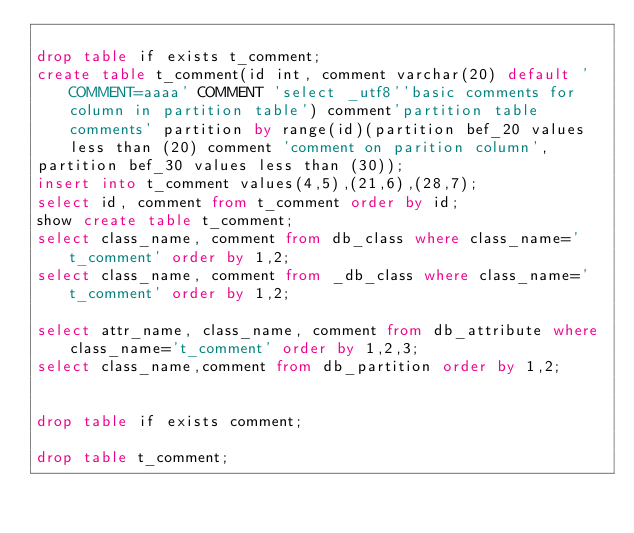<code> <loc_0><loc_0><loc_500><loc_500><_SQL_>
drop table if exists t_comment;
create table t_comment(id int, comment varchar(20) default 'COMMENT=aaaa' COMMENT 'select _utf8''basic comments for column in partition table') comment'partition table comments' partition by range(id)(partition bef_20 values less than (20) comment 'comment on parition column',
partition bef_30 values less than (30));
insert into t_comment values(4,5),(21,6),(28,7);
select id, comment from t_comment order by id;
show create table t_comment;
select class_name, comment from db_class where class_name='t_comment' order by 1,2;
select class_name, comment from _db_class where class_name='t_comment' order by 1,2;

select attr_name, class_name, comment from db_attribute where class_name='t_comment' order by 1,2,3;
select class_name,comment from db_partition order by 1,2; 


drop table if exists comment;

drop table t_comment;
</code> 